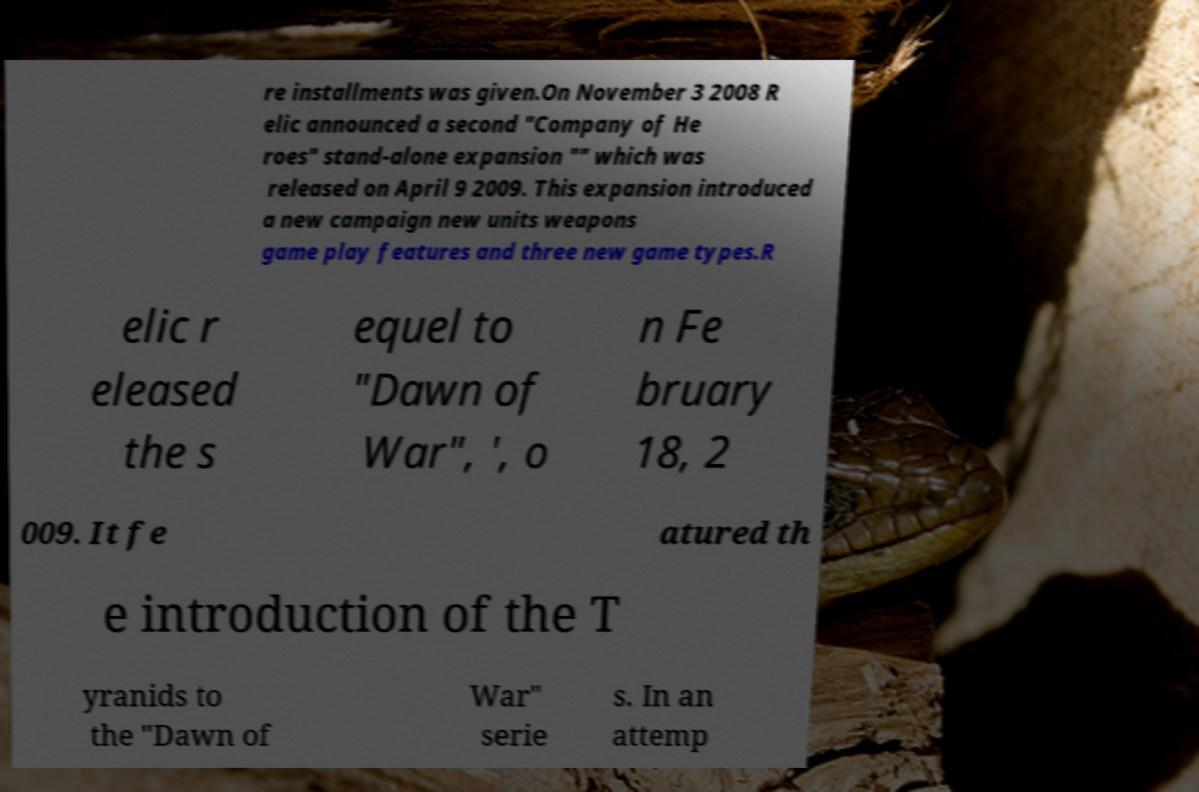For documentation purposes, I need the text within this image transcribed. Could you provide that? re installments was given.On November 3 2008 R elic announced a second "Company of He roes" stand-alone expansion "" which was released on April 9 2009. This expansion introduced a new campaign new units weapons game play features and three new game types.R elic r eleased the s equel to "Dawn of War", ', o n Fe bruary 18, 2 009. It fe atured th e introduction of the T yranids to the "Dawn of War" serie s. In an attemp 